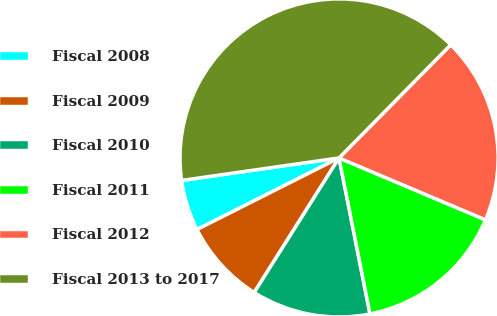Convert chart to OTSL. <chart><loc_0><loc_0><loc_500><loc_500><pie_chart><fcel>Fiscal 2008<fcel>Fiscal 2009<fcel>Fiscal 2010<fcel>Fiscal 2011<fcel>Fiscal 2012<fcel>Fiscal 2013 to 2017<nl><fcel>5.17%<fcel>8.62%<fcel>12.07%<fcel>15.52%<fcel>18.97%<fcel>39.66%<nl></chart> 